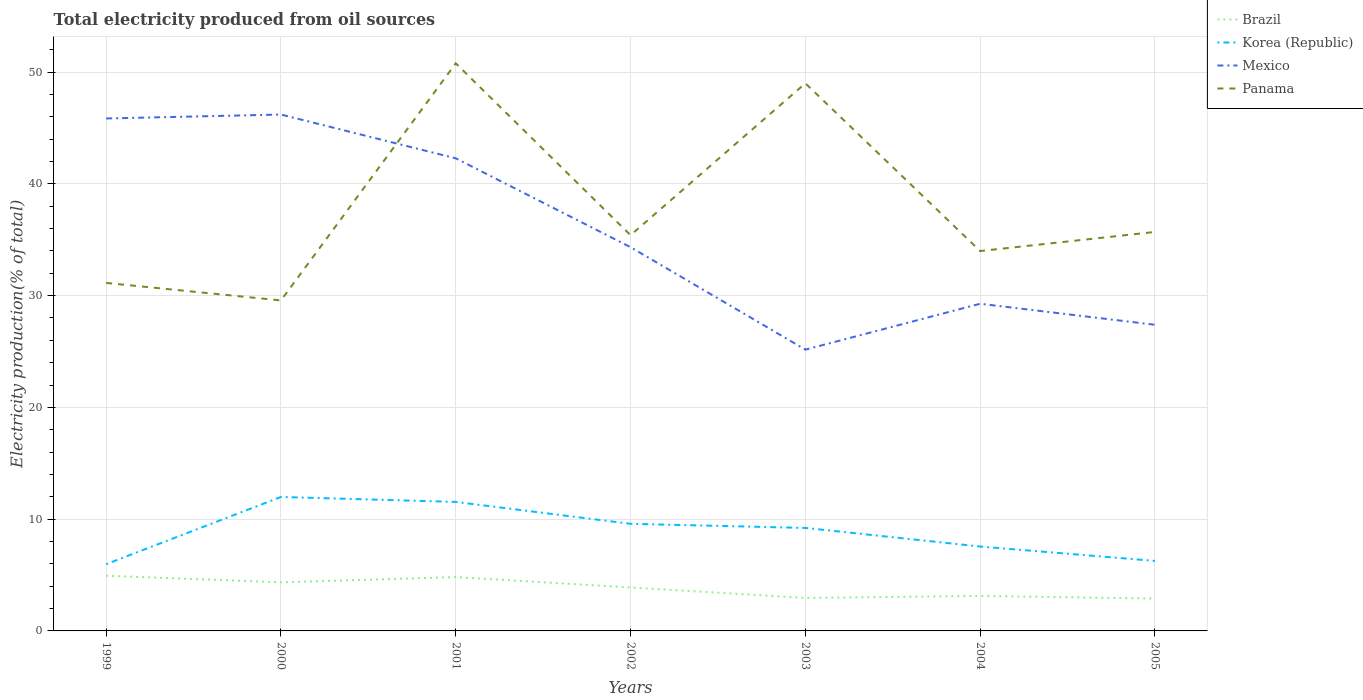How many different coloured lines are there?
Offer a very short reply. 4. Is the number of lines equal to the number of legend labels?
Provide a short and direct response. Yes. Across all years, what is the maximum total electricity produced in Mexico?
Your answer should be compact. 25.17. In which year was the total electricity produced in Korea (Republic) maximum?
Offer a very short reply. 1999. What is the total total electricity produced in Panama in the graph?
Keep it short and to the point. 1.78. What is the difference between the highest and the second highest total electricity produced in Brazil?
Provide a short and direct response. 2.04. What is the difference between the highest and the lowest total electricity produced in Korea (Republic)?
Your response must be concise. 4. Is the total electricity produced in Panama strictly greater than the total electricity produced in Mexico over the years?
Offer a very short reply. No. How many lines are there?
Your answer should be compact. 4. Are the values on the major ticks of Y-axis written in scientific E-notation?
Make the answer very short. No. Where does the legend appear in the graph?
Ensure brevity in your answer.  Top right. What is the title of the graph?
Ensure brevity in your answer.  Total electricity produced from oil sources. What is the label or title of the X-axis?
Provide a short and direct response. Years. What is the label or title of the Y-axis?
Keep it short and to the point. Electricity production(% of total). What is the Electricity production(% of total) in Brazil in 1999?
Your response must be concise. 4.94. What is the Electricity production(% of total) of Korea (Republic) in 1999?
Ensure brevity in your answer.  5.97. What is the Electricity production(% of total) of Mexico in 1999?
Make the answer very short. 45.85. What is the Electricity production(% of total) of Panama in 1999?
Your response must be concise. 31.14. What is the Electricity production(% of total) in Brazil in 2000?
Keep it short and to the point. 4.35. What is the Electricity production(% of total) of Korea (Republic) in 2000?
Your response must be concise. 11.99. What is the Electricity production(% of total) in Mexico in 2000?
Keep it short and to the point. 46.2. What is the Electricity production(% of total) in Panama in 2000?
Keep it short and to the point. 29.57. What is the Electricity production(% of total) of Brazil in 2001?
Keep it short and to the point. 4.82. What is the Electricity production(% of total) of Korea (Republic) in 2001?
Provide a succinct answer. 11.54. What is the Electricity production(% of total) in Mexico in 2001?
Your answer should be compact. 42.28. What is the Electricity production(% of total) in Panama in 2001?
Your response must be concise. 50.78. What is the Electricity production(% of total) of Brazil in 2002?
Your answer should be compact. 3.89. What is the Electricity production(% of total) in Korea (Republic) in 2002?
Offer a terse response. 9.58. What is the Electricity production(% of total) in Mexico in 2002?
Your answer should be very brief. 34.33. What is the Electricity production(% of total) in Panama in 2002?
Give a very brief answer. 35.41. What is the Electricity production(% of total) in Brazil in 2003?
Provide a succinct answer. 2.95. What is the Electricity production(% of total) of Korea (Republic) in 2003?
Ensure brevity in your answer.  9.21. What is the Electricity production(% of total) of Mexico in 2003?
Keep it short and to the point. 25.17. What is the Electricity production(% of total) in Panama in 2003?
Provide a short and direct response. 49. What is the Electricity production(% of total) of Brazil in 2004?
Your response must be concise. 3.13. What is the Electricity production(% of total) in Korea (Republic) in 2004?
Give a very brief answer. 7.55. What is the Electricity production(% of total) in Mexico in 2004?
Keep it short and to the point. 29.27. What is the Electricity production(% of total) of Panama in 2004?
Your answer should be very brief. 33.99. What is the Electricity production(% of total) of Brazil in 2005?
Make the answer very short. 2.9. What is the Electricity production(% of total) of Korea (Republic) in 2005?
Your response must be concise. 6.26. What is the Electricity production(% of total) in Mexico in 2005?
Keep it short and to the point. 27.39. What is the Electricity production(% of total) in Panama in 2005?
Offer a very short reply. 35.7. Across all years, what is the maximum Electricity production(% of total) in Brazil?
Provide a succinct answer. 4.94. Across all years, what is the maximum Electricity production(% of total) of Korea (Republic)?
Provide a short and direct response. 11.99. Across all years, what is the maximum Electricity production(% of total) in Mexico?
Provide a succinct answer. 46.2. Across all years, what is the maximum Electricity production(% of total) in Panama?
Your answer should be very brief. 50.78. Across all years, what is the minimum Electricity production(% of total) in Brazil?
Ensure brevity in your answer.  2.9. Across all years, what is the minimum Electricity production(% of total) of Korea (Republic)?
Provide a short and direct response. 5.97. Across all years, what is the minimum Electricity production(% of total) of Mexico?
Offer a terse response. 25.17. Across all years, what is the minimum Electricity production(% of total) in Panama?
Your answer should be very brief. 29.57. What is the total Electricity production(% of total) of Brazil in the graph?
Give a very brief answer. 26.97. What is the total Electricity production(% of total) of Korea (Republic) in the graph?
Provide a short and direct response. 62.11. What is the total Electricity production(% of total) in Mexico in the graph?
Your answer should be very brief. 250.49. What is the total Electricity production(% of total) in Panama in the graph?
Your response must be concise. 265.57. What is the difference between the Electricity production(% of total) in Brazil in 1999 and that in 2000?
Offer a very short reply. 0.59. What is the difference between the Electricity production(% of total) of Korea (Republic) in 1999 and that in 2000?
Offer a terse response. -6.01. What is the difference between the Electricity production(% of total) in Mexico in 1999 and that in 2000?
Provide a short and direct response. -0.35. What is the difference between the Electricity production(% of total) of Panama in 1999 and that in 2000?
Make the answer very short. 1.57. What is the difference between the Electricity production(% of total) of Brazil in 1999 and that in 2001?
Keep it short and to the point. 0.12. What is the difference between the Electricity production(% of total) in Korea (Republic) in 1999 and that in 2001?
Ensure brevity in your answer.  -5.57. What is the difference between the Electricity production(% of total) of Mexico in 1999 and that in 2001?
Provide a short and direct response. 3.57. What is the difference between the Electricity production(% of total) of Panama in 1999 and that in 2001?
Your response must be concise. -19.65. What is the difference between the Electricity production(% of total) of Brazil in 1999 and that in 2002?
Give a very brief answer. 1.05. What is the difference between the Electricity production(% of total) of Korea (Republic) in 1999 and that in 2002?
Provide a short and direct response. -3.61. What is the difference between the Electricity production(% of total) in Mexico in 1999 and that in 2002?
Ensure brevity in your answer.  11.51. What is the difference between the Electricity production(% of total) in Panama in 1999 and that in 2002?
Your answer should be very brief. -4.27. What is the difference between the Electricity production(% of total) in Brazil in 1999 and that in 2003?
Make the answer very short. 1.98. What is the difference between the Electricity production(% of total) of Korea (Republic) in 1999 and that in 2003?
Give a very brief answer. -3.24. What is the difference between the Electricity production(% of total) in Mexico in 1999 and that in 2003?
Make the answer very short. 20.68. What is the difference between the Electricity production(% of total) of Panama in 1999 and that in 2003?
Ensure brevity in your answer.  -17.86. What is the difference between the Electricity production(% of total) of Brazil in 1999 and that in 2004?
Your response must be concise. 1.81. What is the difference between the Electricity production(% of total) of Korea (Republic) in 1999 and that in 2004?
Make the answer very short. -1.58. What is the difference between the Electricity production(% of total) in Mexico in 1999 and that in 2004?
Keep it short and to the point. 16.58. What is the difference between the Electricity production(% of total) in Panama in 1999 and that in 2004?
Ensure brevity in your answer.  -2.85. What is the difference between the Electricity production(% of total) of Brazil in 1999 and that in 2005?
Your answer should be compact. 2.04. What is the difference between the Electricity production(% of total) of Korea (Republic) in 1999 and that in 2005?
Offer a terse response. -0.29. What is the difference between the Electricity production(% of total) of Mexico in 1999 and that in 2005?
Make the answer very short. 18.46. What is the difference between the Electricity production(% of total) of Panama in 1999 and that in 2005?
Offer a terse response. -4.56. What is the difference between the Electricity production(% of total) of Brazil in 2000 and that in 2001?
Offer a terse response. -0.47. What is the difference between the Electricity production(% of total) of Korea (Republic) in 2000 and that in 2001?
Give a very brief answer. 0.44. What is the difference between the Electricity production(% of total) in Mexico in 2000 and that in 2001?
Provide a short and direct response. 3.92. What is the difference between the Electricity production(% of total) of Panama in 2000 and that in 2001?
Your answer should be compact. -21.21. What is the difference between the Electricity production(% of total) in Brazil in 2000 and that in 2002?
Keep it short and to the point. 0.46. What is the difference between the Electricity production(% of total) of Korea (Republic) in 2000 and that in 2002?
Your answer should be very brief. 2.4. What is the difference between the Electricity production(% of total) in Mexico in 2000 and that in 2002?
Offer a terse response. 11.87. What is the difference between the Electricity production(% of total) of Panama in 2000 and that in 2002?
Offer a terse response. -5.84. What is the difference between the Electricity production(% of total) in Brazil in 2000 and that in 2003?
Your answer should be compact. 1.4. What is the difference between the Electricity production(% of total) in Korea (Republic) in 2000 and that in 2003?
Ensure brevity in your answer.  2.77. What is the difference between the Electricity production(% of total) of Mexico in 2000 and that in 2003?
Your response must be concise. 21.03. What is the difference between the Electricity production(% of total) of Panama in 2000 and that in 2003?
Your response must be concise. -19.43. What is the difference between the Electricity production(% of total) in Brazil in 2000 and that in 2004?
Give a very brief answer. 1.22. What is the difference between the Electricity production(% of total) of Korea (Republic) in 2000 and that in 2004?
Ensure brevity in your answer.  4.44. What is the difference between the Electricity production(% of total) of Mexico in 2000 and that in 2004?
Your answer should be compact. 16.93. What is the difference between the Electricity production(% of total) of Panama in 2000 and that in 2004?
Your response must be concise. -4.42. What is the difference between the Electricity production(% of total) in Brazil in 2000 and that in 2005?
Give a very brief answer. 1.45. What is the difference between the Electricity production(% of total) in Korea (Republic) in 2000 and that in 2005?
Provide a succinct answer. 5.72. What is the difference between the Electricity production(% of total) in Mexico in 2000 and that in 2005?
Offer a terse response. 18.81. What is the difference between the Electricity production(% of total) in Panama in 2000 and that in 2005?
Provide a short and direct response. -6.13. What is the difference between the Electricity production(% of total) in Brazil in 2001 and that in 2002?
Provide a short and direct response. 0.93. What is the difference between the Electricity production(% of total) of Korea (Republic) in 2001 and that in 2002?
Provide a short and direct response. 1.96. What is the difference between the Electricity production(% of total) of Mexico in 2001 and that in 2002?
Your answer should be very brief. 7.95. What is the difference between the Electricity production(% of total) of Panama in 2001 and that in 2002?
Offer a terse response. 15.38. What is the difference between the Electricity production(% of total) in Brazil in 2001 and that in 2003?
Provide a succinct answer. 1.86. What is the difference between the Electricity production(% of total) of Korea (Republic) in 2001 and that in 2003?
Keep it short and to the point. 2.33. What is the difference between the Electricity production(% of total) of Mexico in 2001 and that in 2003?
Provide a short and direct response. 17.12. What is the difference between the Electricity production(% of total) in Panama in 2001 and that in 2003?
Provide a succinct answer. 1.78. What is the difference between the Electricity production(% of total) in Brazil in 2001 and that in 2004?
Provide a short and direct response. 1.68. What is the difference between the Electricity production(% of total) of Korea (Republic) in 2001 and that in 2004?
Offer a terse response. 3.99. What is the difference between the Electricity production(% of total) of Mexico in 2001 and that in 2004?
Give a very brief answer. 13.01. What is the difference between the Electricity production(% of total) of Panama in 2001 and that in 2004?
Your answer should be compact. 16.79. What is the difference between the Electricity production(% of total) in Brazil in 2001 and that in 2005?
Provide a short and direct response. 1.92. What is the difference between the Electricity production(% of total) of Korea (Republic) in 2001 and that in 2005?
Your answer should be compact. 5.28. What is the difference between the Electricity production(% of total) of Mexico in 2001 and that in 2005?
Offer a very short reply. 14.89. What is the difference between the Electricity production(% of total) in Panama in 2001 and that in 2005?
Your answer should be very brief. 15.08. What is the difference between the Electricity production(% of total) in Brazil in 2002 and that in 2003?
Give a very brief answer. 0.94. What is the difference between the Electricity production(% of total) in Korea (Republic) in 2002 and that in 2003?
Make the answer very short. 0.37. What is the difference between the Electricity production(% of total) in Mexico in 2002 and that in 2003?
Make the answer very short. 9.17. What is the difference between the Electricity production(% of total) of Panama in 2002 and that in 2003?
Give a very brief answer. -13.59. What is the difference between the Electricity production(% of total) in Brazil in 2002 and that in 2004?
Your answer should be compact. 0.76. What is the difference between the Electricity production(% of total) in Korea (Republic) in 2002 and that in 2004?
Provide a short and direct response. 2.03. What is the difference between the Electricity production(% of total) of Mexico in 2002 and that in 2004?
Your answer should be very brief. 5.06. What is the difference between the Electricity production(% of total) in Panama in 2002 and that in 2004?
Your response must be concise. 1.42. What is the difference between the Electricity production(% of total) of Brazil in 2002 and that in 2005?
Your answer should be compact. 0.99. What is the difference between the Electricity production(% of total) in Korea (Republic) in 2002 and that in 2005?
Offer a very short reply. 3.32. What is the difference between the Electricity production(% of total) in Mexico in 2002 and that in 2005?
Your answer should be compact. 6.94. What is the difference between the Electricity production(% of total) of Panama in 2002 and that in 2005?
Provide a short and direct response. -0.29. What is the difference between the Electricity production(% of total) of Brazil in 2003 and that in 2004?
Ensure brevity in your answer.  -0.18. What is the difference between the Electricity production(% of total) of Korea (Republic) in 2003 and that in 2004?
Give a very brief answer. 1.66. What is the difference between the Electricity production(% of total) in Mexico in 2003 and that in 2004?
Provide a short and direct response. -4.1. What is the difference between the Electricity production(% of total) in Panama in 2003 and that in 2004?
Keep it short and to the point. 15.01. What is the difference between the Electricity production(% of total) in Brazil in 2003 and that in 2005?
Your response must be concise. 0.05. What is the difference between the Electricity production(% of total) of Korea (Republic) in 2003 and that in 2005?
Your answer should be compact. 2.95. What is the difference between the Electricity production(% of total) in Mexico in 2003 and that in 2005?
Your answer should be compact. -2.22. What is the difference between the Electricity production(% of total) in Panama in 2003 and that in 2005?
Ensure brevity in your answer.  13.3. What is the difference between the Electricity production(% of total) in Brazil in 2004 and that in 2005?
Provide a succinct answer. 0.23. What is the difference between the Electricity production(% of total) of Korea (Republic) in 2004 and that in 2005?
Make the answer very short. 1.29. What is the difference between the Electricity production(% of total) in Mexico in 2004 and that in 2005?
Provide a succinct answer. 1.88. What is the difference between the Electricity production(% of total) of Panama in 2004 and that in 2005?
Your answer should be very brief. -1.71. What is the difference between the Electricity production(% of total) of Brazil in 1999 and the Electricity production(% of total) of Korea (Republic) in 2000?
Your answer should be compact. -7.05. What is the difference between the Electricity production(% of total) in Brazil in 1999 and the Electricity production(% of total) in Mexico in 2000?
Give a very brief answer. -41.26. What is the difference between the Electricity production(% of total) of Brazil in 1999 and the Electricity production(% of total) of Panama in 2000?
Provide a short and direct response. -24.63. What is the difference between the Electricity production(% of total) of Korea (Republic) in 1999 and the Electricity production(% of total) of Mexico in 2000?
Your answer should be very brief. -40.23. What is the difference between the Electricity production(% of total) in Korea (Republic) in 1999 and the Electricity production(% of total) in Panama in 2000?
Your answer should be very brief. -23.6. What is the difference between the Electricity production(% of total) in Mexico in 1999 and the Electricity production(% of total) in Panama in 2000?
Your answer should be very brief. 16.28. What is the difference between the Electricity production(% of total) of Brazil in 1999 and the Electricity production(% of total) of Korea (Republic) in 2001?
Provide a succinct answer. -6.61. What is the difference between the Electricity production(% of total) in Brazil in 1999 and the Electricity production(% of total) in Mexico in 2001?
Your response must be concise. -37.35. What is the difference between the Electricity production(% of total) in Brazil in 1999 and the Electricity production(% of total) in Panama in 2001?
Ensure brevity in your answer.  -45.85. What is the difference between the Electricity production(% of total) in Korea (Republic) in 1999 and the Electricity production(% of total) in Mexico in 2001?
Your response must be concise. -36.31. What is the difference between the Electricity production(% of total) in Korea (Republic) in 1999 and the Electricity production(% of total) in Panama in 2001?
Keep it short and to the point. -44.81. What is the difference between the Electricity production(% of total) of Mexico in 1999 and the Electricity production(% of total) of Panama in 2001?
Keep it short and to the point. -4.93. What is the difference between the Electricity production(% of total) of Brazil in 1999 and the Electricity production(% of total) of Korea (Republic) in 2002?
Offer a terse response. -4.65. What is the difference between the Electricity production(% of total) of Brazil in 1999 and the Electricity production(% of total) of Mexico in 2002?
Offer a terse response. -29.4. What is the difference between the Electricity production(% of total) of Brazil in 1999 and the Electricity production(% of total) of Panama in 2002?
Give a very brief answer. -30.47. What is the difference between the Electricity production(% of total) in Korea (Republic) in 1999 and the Electricity production(% of total) in Mexico in 2002?
Your answer should be compact. -28.36. What is the difference between the Electricity production(% of total) in Korea (Republic) in 1999 and the Electricity production(% of total) in Panama in 2002?
Your answer should be compact. -29.43. What is the difference between the Electricity production(% of total) in Mexico in 1999 and the Electricity production(% of total) in Panama in 2002?
Keep it short and to the point. 10.44. What is the difference between the Electricity production(% of total) in Brazil in 1999 and the Electricity production(% of total) in Korea (Republic) in 2003?
Ensure brevity in your answer.  -4.28. What is the difference between the Electricity production(% of total) in Brazil in 1999 and the Electricity production(% of total) in Mexico in 2003?
Offer a very short reply. -20.23. What is the difference between the Electricity production(% of total) in Brazil in 1999 and the Electricity production(% of total) in Panama in 2003?
Offer a very short reply. -44.06. What is the difference between the Electricity production(% of total) in Korea (Republic) in 1999 and the Electricity production(% of total) in Mexico in 2003?
Your answer should be compact. -19.2. What is the difference between the Electricity production(% of total) of Korea (Republic) in 1999 and the Electricity production(% of total) of Panama in 2003?
Ensure brevity in your answer.  -43.03. What is the difference between the Electricity production(% of total) in Mexico in 1999 and the Electricity production(% of total) in Panama in 2003?
Offer a very short reply. -3.15. What is the difference between the Electricity production(% of total) in Brazil in 1999 and the Electricity production(% of total) in Korea (Republic) in 2004?
Your answer should be very brief. -2.61. What is the difference between the Electricity production(% of total) in Brazil in 1999 and the Electricity production(% of total) in Mexico in 2004?
Your answer should be very brief. -24.34. What is the difference between the Electricity production(% of total) in Brazil in 1999 and the Electricity production(% of total) in Panama in 2004?
Your answer should be very brief. -29.05. What is the difference between the Electricity production(% of total) in Korea (Republic) in 1999 and the Electricity production(% of total) in Mexico in 2004?
Keep it short and to the point. -23.3. What is the difference between the Electricity production(% of total) of Korea (Republic) in 1999 and the Electricity production(% of total) of Panama in 2004?
Offer a terse response. -28.02. What is the difference between the Electricity production(% of total) in Mexico in 1999 and the Electricity production(% of total) in Panama in 2004?
Provide a succinct answer. 11.86. What is the difference between the Electricity production(% of total) in Brazil in 1999 and the Electricity production(% of total) in Korea (Republic) in 2005?
Offer a very short reply. -1.33. What is the difference between the Electricity production(% of total) in Brazil in 1999 and the Electricity production(% of total) in Mexico in 2005?
Provide a short and direct response. -22.46. What is the difference between the Electricity production(% of total) in Brazil in 1999 and the Electricity production(% of total) in Panama in 2005?
Your response must be concise. -30.76. What is the difference between the Electricity production(% of total) of Korea (Republic) in 1999 and the Electricity production(% of total) of Mexico in 2005?
Offer a very short reply. -21.42. What is the difference between the Electricity production(% of total) in Korea (Republic) in 1999 and the Electricity production(% of total) in Panama in 2005?
Your answer should be compact. -29.73. What is the difference between the Electricity production(% of total) in Mexico in 1999 and the Electricity production(% of total) in Panama in 2005?
Provide a short and direct response. 10.15. What is the difference between the Electricity production(% of total) in Brazil in 2000 and the Electricity production(% of total) in Korea (Republic) in 2001?
Offer a very short reply. -7.19. What is the difference between the Electricity production(% of total) in Brazil in 2000 and the Electricity production(% of total) in Mexico in 2001?
Provide a short and direct response. -37.94. What is the difference between the Electricity production(% of total) of Brazil in 2000 and the Electricity production(% of total) of Panama in 2001?
Offer a terse response. -46.43. What is the difference between the Electricity production(% of total) of Korea (Republic) in 2000 and the Electricity production(% of total) of Mexico in 2001?
Offer a very short reply. -30.3. What is the difference between the Electricity production(% of total) in Korea (Republic) in 2000 and the Electricity production(% of total) in Panama in 2001?
Ensure brevity in your answer.  -38.8. What is the difference between the Electricity production(% of total) of Mexico in 2000 and the Electricity production(% of total) of Panama in 2001?
Offer a terse response. -4.58. What is the difference between the Electricity production(% of total) in Brazil in 2000 and the Electricity production(% of total) in Korea (Republic) in 2002?
Offer a terse response. -5.23. What is the difference between the Electricity production(% of total) of Brazil in 2000 and the Electricity production(% of total) of Mexico in 2002?
Offer a very short reply. -29.99. What is the difference between the Electricity production(% of total) in Brazil in 2000 and the Electricity production(% of total) in Panama in 2002?
Offer a terse response. -31.06. What is the difference between the Electricity production(% of total) in Korea (Republic) in 2000 and the Electricity production(% of total) in Mexico in 2002?
Keep it short and to the point. -22.35. What is the difference between the Electricity production(% of total) of Korea (Republic) in 2000 and the Electricity production(% of total) of Panama in 2002?
Keep it short and to the point. -23.42. What is the difference between the Electricity production(% of total) of Mexico in 2000 and the Electricity production(% of total) of Panama in 2002?
Your answer should be very brief. 10.79. What is the difference between the Electricity production(% of total) in Brazil in 2000 and the Electricity production(% of total) in Korea (Republic) in 2003?
Keep it short and to the point. -4.87. What is the difference between the Electricity production(% of total) of Brazil in 2000 and the Electricity production(% of total) of Mexico in 2003?
Ensure brevity in your answer.  -20.82. What is the difference between the Electricity production(% of total) of Brazil in 2000 and the Electricity production(% of total) of Panama in 2003?
Offer a very short reply. -44.65. What is the difference between the Electricity production(% of total) in Korea (Republic) in 2000 and the Electricity production(% of total) in Mexico in 2003?
Your response must be concise. -13.18. What is the difference between the Electricity production(% of total) in Korea (Republic) in 2000 and the Electricity production(% of total) in Panama in 2003?
Ensure brevity in your answer.  -37.01. What is the difference between the Electricity production(% of total) in Mexico in 2000 and the Electricity production(% of total) in Panama in 2003?
Make the answer very short. -2.8. What is the difference between the Electricity production(% of total) of Brazil in 2000 and the Electricity production(% of total) of Korea (Republic) in 2004?
Provide a short and direct response. -3.2. What is the difference between the Electricity production(% of total) of Brazil in 2000 and the Electricity production(% of total) of Mexico in 2004?
Your answer should be very brief. -24.92. What is the difference between the Electricity production(% of total) in Brazil in 2000 and the Electricity production(% of total) in Panama in 2004?
Provide a succinct answer. -29.64. What is the difference between the Electricity production(% of total) in Korea (Republic) in 2000 and the Electricity production(% of total) in Mexico in 2004?
Keep it short and to the point. -17.29. What is the difference between the Electricity production(% of total) of Korea (Republic) in 2000 and the Electricity production(% of total) of Panama in 2004?
Provide a short and direct response. -22. What is the difference between the Electricity production(% of total) of Mexico in 2000 and the Electricity production(% of total) of Panama in 2004?
Make the answer very short. 12.21. What is the difference between the Electricity production(% of total) in Brazil in 2000 and the Electricity production(% of total) in Korea (Republic) in 2005?
Offer a terse response. -1.92. What is the difference between the Electricity production(% of total) in Brazil in 2000 and the Electricity production(% of total) in Mexico in 2005?
Offer a very short reply. -23.04. What is the difference between the Electricity production(% of total) in Brazil in 2000 and the Electricity production(% of total) in Panama in 2005?
Your response must be concise. -31.35. What is the difference between the Electricity production(% of total) of Korea (Republic) in 2000 and the Electricity production(% of total) of Mexico in 2005?
Ensure brevity in your answer.  -15.41. What is the difference between the Electricity production(% of total) in Korea (Republic) in 2000 and the Electricity production(% of total) in Panama in 2005?
Provide a short and direct response. -23.71. What is the difference between the Electricity production(% of total) in Mexico in 2000 and the Electricity production(% of total) in Panama in 2005?
Give a very brief answer. 10.5. What is the difference between the Electricity production(% of total) in Brazil in 2001 and the Electricity production(% of total) in Korea (Republic) in 2002?
Your response must be concise. -4.77. What is the difference between the Electricity production(% of total) in Brazil in 2001 and the Electricity production(% of total) in Mexico in 2002?
Provide a short and direct response. -29.52. What is the difference between the Electricity production(% of total) of Brazil in 2001 and the Electricity production(% of total) of Panama in 2002?
Make the answer very short. -30.59. What is the difference between the Electricity production(% of total) in Korea (Republic) in 2001 and the Electricity production(% of total) in Mexico in 2002?
Provide a succinct answer. -22.79. What is the difference between the Electricity production(% of total) of Korea (Republic) in 2001 and the Electricity production(% of total) of Panama in 2002?
Provide a succinct answer. -23.86. What is the difference between the Electricity production(% of total) of Mexico in 2001 and the Electricity production(% of total) of Panama in 2002?
Make the answer very short. 6.88. What is the difference between the Electricity production(% of total) of Brazil in 2001 and the Electricity production(% of total) of Korea (Republic) in 2003?
Provide a succinct answer. -4.4. What is the difference between the Electricity production(% of total) in Brazil in 2001 and the Electricity production(% of total) in Mexico in 2003?
Provide a short and direct response. -20.35. What is the difference between the Electricity production(% of total) of Brazil in 2001 and the Electricity production(% of total) of Panama in 2003?
Your response must be concise. -44.18. What is the difference between the Electricity production(% of total) of Korea (Republic) in 2001 and the Electricity production(% of total) of Mexico in 2003?
Offer a very short reply. -13.62. What is the difference between the Electricity production(% of total) in Korea (Republic) in 2001 and the Electricity production(% of total) in Panama in 2003?
Make the answer very short. -37.45. What is the difference between the Electricity production(% of total) in Mexico in 2001 and the Electricity production(% of total) in Panama in 2003?
Provide a short and direct response. -6.71. What is the difference between the Electricity production(% of total) in Brazil in 2001 and the Electricity production(% of total) in Korea (Republic) in 2004?
Offer a very short reply. -2.74. What is the difference between the Electricity production(% of total) in Brazil in 2001 and the Electricity production(% of total) in Mexico in 2004?
Your answer should be compact. -24.46. What is the difference between the Electricity production(% of total) of Brazil in 2001 and the Electricity production(% of total) of Panama in 2004?
Offer a very short reply. -29.17. What is the difference between the Electricity production(% of total) in Korea (Republic) in 2001 and the Electricity production(% of total) in Mexico in 2004?
Give a very brief answer. -17.73. What is the difference between the Electricity production(% of total) of Korea (Republic) in 2001 and the Electricity production(% of total) of Panama in 2004?
Make the answer very short. -22.44. What is the difference between the Electricity production(% of total) of Mexico in 2001 and the Electricity production(% of total) of Panama in 2004?
Provide a short and direct response. 8.3. What is the difference between the Electricity production(% of total) in Brazil in 2001 and the Electricity production(% of total) in Korea (Republic) in 2005?
Offer a terse response. -1.45. What is the difference between the Electricity production(% of total) of Brazil in 2001 and the Electricity production(% of total) of Mexico in 2005?
Offer a very short reply. -22.58. What is the difference between the Electricity production(% of total) in Brazil in 2001 and the Electricity production(% of total) in Panama in 2005?
Make the answer very short. -30.88. What is the difference between the Electricity production(% of total) in Korea (Republic) in 2001 and the Electricity production(% of total) in Mexico in 2005?
Ensure brevity in your answer.  -15.85. What is the difference between the Electricity production(% of total) of Korea (Republic) in 2001 and the Electricity production(% of total) of Panama in 2005?
Give a very brief answer. -24.15. What is the difference between the Electricity production(% of total) of Mexico in 2001 and the Electricity production(% of total) of Panama in 2005?
Your answer should be very brief. 6.59. What is the difference between the Electricity production(% of total) of Brazil in 2002 and the Electricity production(% of total) of Korea (Republic) in 2003?
Offer a very short reply. -5.33. What is the difference between the Electricity production(% of total) in Brazil in 2002 and the Electricity production(% of total) in Mexico in 2003?
Offer a terse response. -21.28. What is the difference between the Electricity production(% of total) of Brazil in 2002 and the Electricity production(% of total) of Panama in 2003?
Give a very brief answer. -45.11. What is the difference between the Electricity production(% of total) of Korea (Republic) in 2002 and the Electricity production(% of total) of Mexico in 2003?
Your answer should be very brief. -15.58. What is the difference between the Electricity production(% of total) of Korea (Republic) in 2002 and the Electricity production(% of total) of Panama in 2003?
Provide a succinct answer. -39.41. What is the difference between the Electricity production(% of total) of Mexico in 2002 and the Electricity production(% of total) of Panama in 2003?
Your answer should be very brief. -14.66. What is the difference between the Electricity production(% of total) in Brazil in 2002 and the Electricity production(% of total) in Korea (Republic) in 2004?
Your response must be concise. -3.66. What is the difference between the Electricity production(% of total) in Brazil in 2002 and the Electricity production(% of total) in Mexico in 2004?
Your answer should be compact. -25.38. What is the difference between the Electricity production(% of total) of Brazil in 2002 and the Electricity production(% of total) of Panama in 2004?
Your response must be concise. -30.1. What is the difference between the Electricity production(% of total) of Korea (Republic) in 2002 and the Electricity production(% of total) of Mexico in 2004?
Offer a very short reply. -19.69. What is the difference between the Electricity production(% of total) in Korea (Republic) in 2002 and the Electricity production(% of total) in Panama in 2004?
Provide a short and direct response. -24.4. What is the difference between the Electricity production(% of total) in Mexico in 2002 and the Electricity production(% of total) in Panama in 2004?
Offer a terse response. 0.35. What is the difference between the Electricity production(% of total) of Brazil in 2002 and the Electricity production(% of total) of Korea (Republic) in 2005?
Offer a very short reply. -2.38. What is the difference between the Electricity production(% of total) in Brazil in 2002 and the Electricity production(% of total) in Mexico in 2005?
Provide a short and direct response. -23.5. What is the difference between the Electricity production(% of total) in Brazil in 2002 and the Electricity production(% of total) in Panama in 2005?
Give a very brief answer. -31.81. What is the difference between the Electricity production(% of total) of Korea (Republic) in 2002 and the Electricity production(% of total) of Mexico in 2005?
Offer a very short reply. -17.81. What is the difference between the Electricity production(% of total) in Korea (Republic) in 2002 and the Electricity production(% of total) in Panama in 2005?
Ensure brevity in your answer.  -26.11. What is the difference between the Electricity production(% of total) of Mexico in 2002 and the Electricity production(% of total) of Panama in 2005?
Make the answer very short. -1.36. What is the difference between the Electricity production(% of total) in Brazil in 2003 and the Electricity production(% of total) in Korea (Republic) in 2004?
Give a very brief answer. -4.6. What is the difference between the Electricity production(% of total) in Brazil in 2003 and the Electricity production(% of total) in Mexico in 2004?
Offer a terse response. -26.32. What is the difference between the Electricity production(% of total) in Brazil in 2003 and the Electricity production(% of total) in Panama in 2004?
Make the answer very short. -31.04. What is the difference between the Electricity production(% of total) of Korea (Republic) in 2003 and the Electricity production(% of total) of Mexico in 2004?
Offer a terse response. -20.06. What is the difference between the Electricity production(% of total) of Korea (Republic) in 2003 and the Electricity production(% of total) of Panama in 2004?
Your response must be concise. -24.77. What is the difference between the Electricity production(% of total) in Mexico in 2003 and the Electricity production(% of total) in Panama in 2004?
Provide a short and direct response. -8.82. What is the difference between the Electricity production(% of total) of Brazil in 2003 and the Electricity production(% of total) of Korea (Republic) in 2005?
Offer a very short reply. -3.31. What is the difference between the Electricity production(% of total) of Brazil in 2003 and the Electricity production(% of total) of Mexico in 2005?
Offer a terse response. -24.44. What is the difference between the Electricity production(% of total) in Brazil in 2003 and the Electricity production(% of total) in Panama in 2005?
Give a very brief answer. -32.74. What is the difference between the Electricity production(% of total) in Korea (Republic) in 2003 and the Electricity production(% of total) in Mexico in 2005?
Your answer should be compact. -18.18. What is the difference between the Electricity production(% of total) in Korea (Republic) in 2003 and the Electricity production(% of total) in Panama in 2005?
Give a very brief answer. -26.48. What is the difference between the Electricity production(% of total) of Mexico in 2003 and the Electricity production(% of total) of Panama in 2005?
Give a very brief answer. -10.53. What is the difference between the Electricity production(% of total) of Brazil in 2004 and the Electricity production(% of total) of Korea (Republic) in 2005?
Your answer should be compact. -3.13. What is the difference between the Electricity production(% of total) in Brazil in 2004 and the Electricity production(% of total) in Mexico in 2005?
Ensure brevity in your answer.  -24.26. What is the difference between the Electricity production(% of total) of Brazil in 2004 and the Electricity production(% of total) of Panama in 2005?
Make the answer very short. -32.57. What is the difference between the Electricity production(% of total) of Korea (Republic) in 2004 and the Electricity production(% of total) of Mexico in 2005?
Keep it short and to the point. -19.84. What is the difference between the Electricity production(% of total) of Korea (Republic) in 2004 and the Electricity production(% of total) of Panama in 2005?
Provide a succinct answer. -28.15. What is the difference between the Electricity production(% of total) of Mexico in 2004 and the Electricity production(% of total) of Panama in 2005?
Offer a very short reply. -6.42. What is the average Electricity production(% of total) of Brazil per year?
Ensure brevity in your answer.  3.85. What is the average Electricity production(% of total) in Korea (Republic) per year?
Provide a short and direct response. 8.87. What is the average Electricity production(% of total) of Mexico per year?
Offer a very short reply. 35.78. What is the average Electricity production(% of total) of Panama per year?
Keep it short and to the point. 37.94. In the year 1999, what is the difference between the Electricity production(% of total) in Brazil and Electricity production(% of total) in Korea (Republic)?
Offer a very short reply. -1.03. In the year 1999, what is the difference between the Electricity production(% of total) in Brazil and Electricity production(% of total) in Mexico?
Your answer should be compact. -40.91. In the year 1999, what is the difference between the Electricity production(% of total) in Brazil and Electricity production(% of total) in Panama?
Your answer should be very brief. -26.2. In the year 1999, what is the difference between the Electricity production(% of total) in Korea (Republic) and Electricity production(% of total) in Mexico?
Ensure brevity in your answer.  -39.88. In the year 1999, what is the difference between the Electricity production(% of total) of Korea (Republic) and Electricity production(% of total) of Panama?
Offer a terse response. -25.16. In the year 1999, what is the difference between the Electricity production(% of total) of Mexico and Electricity production(% of total) of Panama?
Make the answer very short. 14.71. In the year 2000, what is the difference between the Electricity production(% of total) in Brazil and Electricity production(% of total) in Korea (Republic)?
Provide a succinct answer. -7.64. In the year 2000, what is the difference between the Electricity production(% of total) in Brazil and Electricity production(% of total) in Mexico?
Make the answer very short. -41.85. In the year 2000, what is the difference between the Electricity production(% of total) in Brazil and Electricity production(% of total) in Panama?
Make the answer very short. -25.22. In the year 2000, what is the difference between the Electricity production(% of total) in Korea (Republic) and Electricity production(% of total) in Mexico?
Your answer should be compact. -34.21. In the year 2000, what is the difference between the Electricity production(% of total) in Korea (Republic) and Electricity production(% of total) in Panama?
Give a very brief answer. -17.58. In the year 2000, what is the difference between the Electricity production(% of total) in Mexico and Electricity production(% of total) in Panama?
Your response must be concise. 16.63. In the year 2001, what is the difference between the Electricity production(% of total) in Brazil and Electricity production(% of total) in Korea (Republic)?
Provide a short and direct response. -6.73. In the year 2001, what is the difference between the Electricity production(% of total) in Brazil and Electricity production(% of total) in Mexico?
Your answer should be compact. -37.47. In the year 2001, what is the difference between the Electricity production(% of total) of Brazil and Electricity production(% of total) of Panama?
Offer a terse response. -45.97. In the year 2001, what is the difference between the Electricity production(% of total) of Korea (Republic) and Electricity production(% of total) of Mexico?
Make the answer very short. -30.74. In the year 2001, what is the difference between the Electricity production(% of total) of Korea (Republic) and Electricity production(% of total) of Panama?
Keep it short and to the point. -39.24. In the year 2001, what is the difference between the Electricity production(% of total) in Mexico and Electricity production(% of total) in Panama?
Provide a succinct answer. -8.5. In the year 2002, what is the difference between the Electricity production(% of total) in Brazil and Electricity production(% of total) in Korea (Republic)?
Your answer should be very brief. -5.69. In the year 2002, what is the difference between the Electricity production(% of total) in Brazil and Electricity production(% of total) in Mexico?
Ensure brevity in your answer.  -30.45. In the year 2002, what is the difference between the Electricity production(% of total) of Brazil and Electricity production(% of total) of Panama?
Your response must be concise. -31.52. In the year 2002, what is the difference between the Electricity production(% of total) of Korea (Republic) and Electricity production(% of total) of Mexico?
Your answer should be compact. -24.75. In the year 2002, what is the difference between the Electricity production(% of total) in Korea (Republic) and Electricity production(% of total) in Panama?
Ensure brevity in your answer.  -25.82. In the year 2002, what is the difference between the Electricity production(% of total) of Mexico and Electricity production(% of total) of Panama?
Give a very brief answer. -1.07. In the year 2003, what is the difference between the Electricity production(% of total) of Brazil and Electricity production(% of total) of Korea (Republic)?
Your response must be concise. -6.26. In the year 2003, what is the difference between the Electricity production(% of total) in Brazil and Electricity production(% of total) in Mexico?
Provide a short and direct response. -22.22. In the year 2003, what is the difference between the Electricity production(% of total) of Brazil and Electricity production(% of total) of Panama?
Make the answer very short. -46.04. In the year 2003, what is the difference between the Electricity production(% of total) of Korea (Republic) and Electricity production(% of total) of Mexico?
Your answer should be compact. -15.95. In the year 2003, what is the difference between the Electricity production(% of total) in Korea (Republic) and Electricity production(% of total) in Panama?
Your answer should be compact. -39.78. In the year 2003, what is the difference between the Electricity production(% of total) in Mexico and Electricity production(% of total) in Panama?
Keep it short and to the point. -23.83. In the year 2004, what is the difference between the Electricity production(% of total) of Brazil and Electricity production(% of total) of Korea (Republic)?
Give a very brief answer. -4.42. In the year 2004, what is the difference between the Electricity production(% of total) in Brazil and Electricity production(% of total) in Mexico?
Keep it short and to the point. -26.14. In the year 2004, what is the difference between the Electricity production(% of total) of Brazil and Electricity production(% of total) of Panama?
Offer a very short reply. -30.86. In the year 2004, what is the difference between the Electricity production(% of total) of Korea (Republic) and Electricity production(% of total) of Mexico?
Your answer should be very brief. -21.72. In the year 2004, what is the difference between the Electricity production(% of total) in Korea (Republic) and Electricity production(% of total) in Panama?
Keep it short and to the point. -26.44. In the year 2004, what is the difference between the Electricity production(% of total) of Mexico and Electricity production(% of total) of Panama?
Give a very brief answer. -4.72. In the year 2005, what is the difference between the Electricity production(% of total) of Brazil and Electricity production(% of total) of Korea (Republic)?
Make the answer very short. -3.37. In the year 2005, what is the difference between the Electricity production(% of total) in Brazil and Electricity production(% of total) in Mexico?
Offer a very short reply. -24.49. In the year 2005, what is the difference between the Electricity production(% of total) in Brazil and Electricity production(% of total) in Panama?
Your answer should be very brief. -32.8. In the year 2005, what is the difference between the Electricity production(% of total) in Korea (Republic) and Electricity production(% of total) in Mexico?
Your answer should be compact. -21.13. In the year 2005, what is the difference between the Electricity production(% of total) of Korea (Republic) and Electricity production(% of total) of Panama?
Your answer should be very brief. -29.43. In the year 2005, what is the difference between the Electricity production(% of total) of Mexico and Electricity production(% of total) of Panama?
Provide a short and direct response. -8.31. What is the ratio of the Electricity production(% of total) of Brazil in 1999 to that in 2000?
Provide a succinct answer. 1.14. What is the ratio of the Electricity production(% of total) of Korea (Republic) in 1999 to that in 2000?
Ensure brevity in your answer.  0.5. What is the ratio of the Electricity production(% of total) in Mexico in 1999 to that in 2000?
Your response must be concise. 0.99. What is the ratio of the Electricity production(% of total) of Panama in 1999 to that in 2000?
Offer a very short reply. 1.05. What is the ratio of the Electricity production(% of total) of Brazil in 1999 to that in 2001?
Your answer should be compact. 1.02. What is the ratio of the Electricity production(% of total) in Korea (Republic) in 1999 to that in 2001?
Offer a terse response. 0.52. What is the ratio of the Electricity production(% of total) in Mexico in 1999 to that in 2001?
Keep it short and to the point. 1.08. What is the ratio of the Electricity production(% of total) in Panama in 1999 to that in 2001?
Keep it short and to the point. 0.61. What is the ratio of the Electricity production(% of total) of Brazil in 1999 to that in 2002?
Make the answer very short. 1.27. What is the ratio of the Electricity production(% of total) in Korea (Republic) in 1999 to that in 2002?
Offer a very short reply. 0.62. What is the ratio of the Electricity production(% of total) of Mexico in 1999 to that in 2002?
Offer a terse response. 1.34. What is the ratio of the Electricity production(% of total) in Panama in 1999 to that in 2002?
Ensure brevity in your answer.  0.88. What is the ratio of the Electricity production(% of total) in Brazil in 1999 to that in 2003?
Your response must be concise. 1.67. What is the ratio of the Electricity production(% of total) in Korea (Republic) in 1999 to that in 2003?
Keep it short and to the point. 0.65. What is the ratio of the Electricity production(% of total) of Mexico in 1999 to that in 2003?
Provide a succinct answer. 1.82. What is the ratio of the Electricity production(% of total) in Panama in 1999 to that in 2003?
Your answer should be very brief. 0.64. What is the ratio of the Electricity production(% of total) in Brazil in 1999 to that in 2004?
Your answer should be compact. 1.58. What is the ratio of the Electricity production(% of total) of Korea (Republic) in 1999 to that in 2004?
Offer a terse response. 0.79. What is the ratio of the Electricity production(% of total) of Mexico in 1999 to that in 2004?
Your response must be concise. 1.57. What is the ratio of the Electricity production(% of total) of Panama in 1999 to that in 2004?
Give a very brief answer. 0.92. What is the ratio of the Electricity production(% of total) in Brazil in 1999 to that in 2005?
Keep it short and to the point. 1.7. What is the ratio of the Electricity production(% of total) in Korea (Republic) in 1999 to that in 2005?
Offer a terse response. 0.95. What is the ratio of the Electricity production(% of total) of Mexico in 1999 to that in 2005?
Your answer should be compact. 1.67. What is the ratio of the Electricity production(% of total) of Panama in 1999 to that in 2005?
Keep it short and to the point. 0.87. What is the ratio of the Electricity production(% of total) in Brazil in 2000 to that in 2001?
Ensure brevity in your answer.  0.9. What is the ratio of the Electricity production(% of total) of Korea (Republic) in 2000 to that in 2001?
Ensure brevity in your answer.  1.04. What is the ratio of the Electricity production(% of total) in Mexico in 2000 to that in 2001?
Offer a terse response. 1.09. What is the ratio of the Electricity production(% of total) in Panama in 2000 to that in 2001?
Offer a terse response. 0.58. What is the ratio of the Electricity production(% of total) in Brazil in 2000 to that in 2002?
Your answer should be compact. 1.12. What is the ratio of the Electricity production(% of total) in Korea (Republic) in 2000 to that in 2002?
Your answer should be compact. 1.25. What is the ratio of the Electricity production(% of total) of Mexico in 2000 to that in 2002?
Provide a short and direct response. 1.35. What is the ratio of the Electricity production(% of total) of Panama in 2000 to that in 2002?
Make the answer very short. 0.84. What is the ratio of the Electricity production(% of total) in Brazil in 2000 to that in 2003?
Make the answer very short. 1.47. What is the ratio of the Electricity production(% of total) in Korea (Republic) in 2000 to that in 2003?
Your answer should be compact. 1.3. What is the ratio of the Electricity production(% of total) of Mexico in 2000 to that in 2003?
Keep it short and to the point. 1.84. What is the ratio of the Electricity production(% of total) of Panama in 2000 to that in 2003?
Offer a very short reply. 0.6. What is the ratio of the Electricity production(% of total) of Brazil in 2000 to that in 2004?
Offer a very short reply. 1.39. What is the ratio of the Electricity production(% of total) of Korea (Republic) in 2000 to that in 2004?
Your answer should be compact. 1.59. What is the ratio of the Electricity production(% of total) in Mexico in 2000 to that in 2004?
Provide a succinct answer. 1.58. What is the ratio of the Electricity production(% of total) of Panama in 2000 to that in 2004?
Provide a succinct answer. 0.87. What is the ratio of the Electricity production(% of total) in Brazil in 2000 to that in 2005?
Provide a short and direct response. 1.5. What is the ratio of the Electricity production(% of total) in Korea (Republic) in 2000 to that in 2005?
Offer a very short reply. 1.91. What is the ratio of the Electricity production(% of total) of Mexico in 2000 to that in 2005?
Provide a succinct answer. 1.69. What is the ratio of the Electricity production(% of total) in Panama in 2000 to that in 2005?
Offer a terse response. 0.83. What is the ratio of the Electricity production(% of total) of Brazil in 2001 to that in 2002?
Give a very brief answer. 1.24. What is the ratio of the Electricity production(% of total) in Korea (Republic) in 2001 to that in 2002?
Give a very brief answer. 1.2. What is the ratio of the Electricity production(% of total) of Mexico in 2001 to that in 2002?
Keep it short and to the point. 1.23. What is the ratio of the Electricity production(% of total) in Panama in 2001 to that in 2002?
Your answer should be very brief. 1.43. What is the ratio of the Electricity production(% of total) of Brazil in 2001 to that in 2003?
Ensure brevity in your answer.  1.63. What is the ratio of the Electricity production(% of total) in Korea (Republic) in 2001 to that in 2003?
Offer a terse response. 1.25. What is the ratio of the Electricity production(% of total) of Mexico in 2001 to that in 2003?
Give a very brief answer. 1.68. What is the ratio of the Electricity production(% of total) of Panama in 2001 to that in 2003?
Offer a very short reply. 1.04. What is the ratio of the Electricity production(% of total) in Brazil in 2001 to that in 2004?
Keep it short and to the point. 1.54. What is the ratio of the Electricity production(% of total) in Korea (Republic) in 2001 to that in 2004?
Provide a short and direct response. 1.53. What is the ratio of the Electricity production(% of total) in Mexico in 2001 to that in 2004?
Keep it short and to the point. 1.44. What is the ratio of the Electricity production(% of total) of Panama in 2001 to that in 2004?
Keep it short and to the point. 1.49. What is the ratio of the Electricity production(% of total) in Brazil in 2001 to that in 2005?
Your response must be concise. 1.66. What is the ratio of the Electricity production(% of total) of Korea (Republic) in 2001 to that in 2005?
Provide a short and direct response. 1.84. What is the ratio of the Electricity production(% of total) in Mexico in 2001 to that in 2005?
Ensure brevity in your answer.  1.54. What is the ratio of the Electricity production(% of total) of Panama in 2001 to that in 2005?
Your response must be concise. 1.42. What is the ratio of the Electricity production(% of total) in Brazil in 2002 to that in 2003?
Make the answer very short. 1.32. What is the ratio of the Electricity production(% of total) in Korea (Republic) in 2002 to that in 2003?
Make the answer very short. 1.04. What is the ratio of the Electricity production(% of total) in Mexico in 2002 to that in 2003?
Your answer should be very brief. 1.36. What is the ratio of the Electricity production(% of total) of Panama in 2002 to that in 2003?
Provide a succinct answer. 0.72. What is the ratio of the Electricity production(% of total) in Brazil in 2002 to that in 2004?
Give a very brief answer. 1.24. What is the ratio of the Electricity production(% of total) of Korea (Republic) in 2002 to that in 2004?
Offer a terse response. 1.27. What is the ratio of the Electricity production(% of total) in Mexico in 2002 to that in 2004?
Keep it short and to the point. 1.17. What is the ratio of the Electricity production(% of total) of Panama in 2002 to that in 2004?
Give a very brief answer. 1.04. What is the ratio of the Electricity production(% of total) in Brazil in 2002 to that in 2005?
Offer a terse response. 1.34. What is the ratio of the Electricity production(% of total) in Korea (Republic) in 2002 to that in 2005?
Give a very brief answer. 1.53. What is the ratio of the Electricity production(% of total) of Mexico in 2002 to that in 2005?
Your answer should be compact. 1.25. What is the ratio of the Electricity production(% of total) in Panama in 2002 to that in 2005?
Offer a very short reply. 0.99. What is the ratio of the Electricity production(% of total) in Brazil in 2003 to that in 2004?
Provide a short and direct response. 0.94. What is the ratio of the Electricity production(% of total) of Korea (Republic) in 2003 to that in 2004?
Your response must be concise. 1.22. What is the ratio of the Electricity production(% of total) of Mexico in 2003 to that in 2004?
Your answer should be compact. 0.86. What is the ratio of the Electricity production(% of total) in Panama in 2003 to that in 2004?
Provide a succinct answer. 1.44. What is the ratio of the Electricity production(% of total) in Brazil in 2003 to that in 2005?
Offer a terse response. 1.02. What is the ratio of the Electricity production(% of total) of Korea (Republic) in 2003 to that in 2005?
Keep it short and to the point. 1.47. What is the ratio of the Electricity production(% of total) of Mexico in 2003 to that in 2005?
Offer a terse response. 0.92. What is the ratio of the Electricity production(% of total) in Panama in 2003 to that in 2005?
Offer a very short reply. 1.37. What is the ratio of the Electricity production(% of total) of Brazil in 2004 to that in 2005?
Offer a terse response. 1.08. What is the ratio of the Electricity production(% of total) in Korea (Republic) in 2004 to that in 2005?
Keep it short and to the point. 1.21. What is the ratio of the Electricity production(% of total) of Mexico in 2004 to that in 2005?
Your answer should be very brief. 1.07. What is the ratio of the Electricity production(% of total) of Panama in 2004 to that in 2005?
Your response must be concise. 0.95. What is the difference between the highest and the second highest Electricity production(% of total) in Brazil?
Provide a succinct answer. 0.12. What is the difference between the highest and the second highest Electricity production(% of total) of Korea (Republic)?
Your answer should be very brief. 0.44. What is the difference between the highest and the second highest Electricity production(% of total) of Mexico?
Keep it short and to the point. 0.35. What is the difference between the highest and the second highest Electricity production(% of total) in Panama?
Make the answer very short. 1.78. What is the difference between the highest and the lowest Electricity production(% of total) in Brazil?
Provide a short and direct response. 2.04. What is the difference between the highest and the lowest Electricity production(% of total) of Korea (Republic)?
Give a very brief answer. 6.01. What is the difference between the highest and the lowest Electricity production(% of total) of Mexico?
Give a very brief answer. 21.03. What is the difference between the highest and the lowest Electricity production(% of total) of Panama?
Make the answer very short. 21.21. 